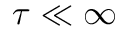Convert formula to latex. <formula><loc_0><loc_0><loc_500><loc_500>\tau \ll \infty</formula> 